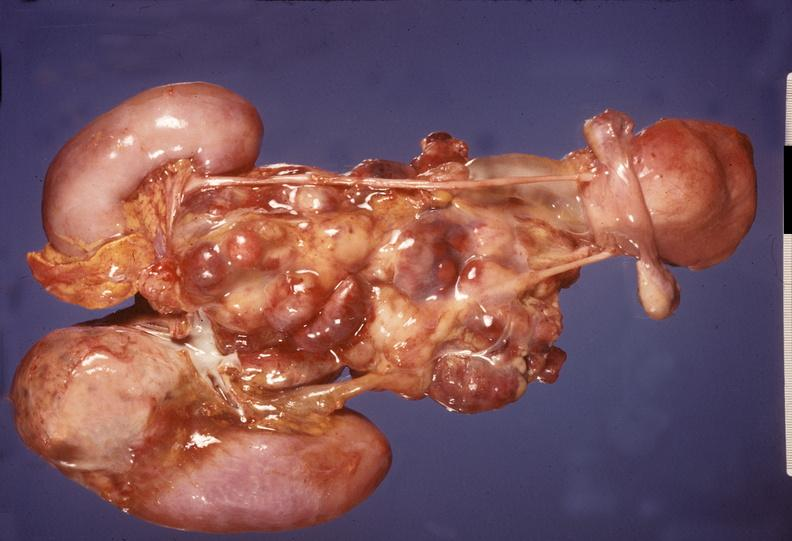does peritoneal fluid show adrenal, neuroblastoma?
Answer the question using a single word or phrase. No 